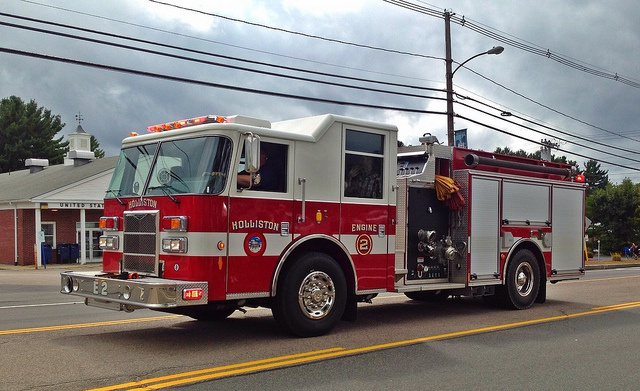Describe the objects in this image and their specific colors. I can see truck in lightgray, black, darkgray, maroon, and gray tones, people in lightgray and black tones, people in lightgray, black, maroon, and brown tones, and people in lightgray, black, gray, and maroon tones in this image. 